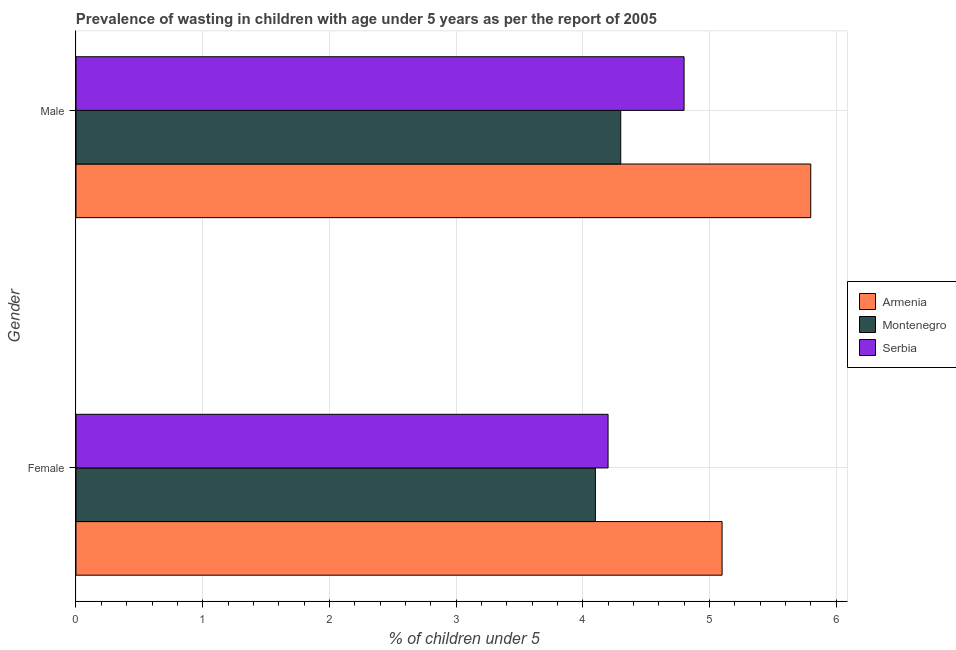Are the number of bars per tick equal to the number of legend labels?
Ensure brevity in your answer.  Yes. How many bars are there on the 1st tick from the bottom?
Provide a succinct answer. 3. What is the percentage of undernourished female children in Armenia?
Ensure brevity in your answer.  5.1. Across all countries, what is the maximum percentage of undernourished female children?
Give a very brief answer. 5.1. Across all countries, what is the minimum percentage of undernourished male children?
Give a very brief answer. 4.3. In which country was the percentage of undernourished male children maximum?
Your answer should be very brief. Armenia. In which country was the percentage of undernourished male children minimum?
Make the answer very short. Montenegro. What is the total percentage of undernourished male children in the graph?
Give a very brief answer. 14.9. What is the difference between the percentage of undernourished female children in Armenia and that in Serbia?
Make the answer very short. 0.9. What is the difference between the percentage of undernourished male children in Armenia and the percentage of undernourished female children in Serbia?
Offer a terse response. 1.6. What is the average percentage of undernourished male children per country?
Ensure brevity in your answer.  4.97. What is the difference between the percentage of undernourished male children and percentage of undernourished female children in Serbia?
Make the answer very short. 0.6. What is the ratio of the percentage of undernourished male children in Armenia to that in Montenegro?
Your response must be concise. 1.35. Is the percentage of undernourished female children in Montenegro less than that in Serbia?
Give a very brief answer. Yes. In how many countries, is the percentage of undernourished female children greater than the average percentage of undernourished female children taken over all countries?
Offer a terse response. 1. What does the 1st bar from the top in Male represents?
Keep it short and to the point. Serbia. What does the 2nd bar from the bottom in Female represents?
Offer a very short reply. Montenegro. Does the graph contain any zero values?
Ensure brevity in your answer.  No. What is the title of the graph?
Your answer should be compact. Prevalence of wasting in children with age under 5 years as per the report of 2005. Does "Spain" appear as one of the legend labels in the graph?
Provide a succinct answer. No. What is the label or title of the X-axis?
Provide a succinct answer.  % of children under 5. What is the label or title of the Y-axis?
Your answer should be compact. Gender. What is the  % of children under 5 of Armenia in Female?
Your answer should be very brief. 5.1. What is the  % of children under 5 of Montenegro in Female?
Your answer should be very brief. 4.1. What is the  % of children under 5 in Serbia in Female?
Your answer should be compact. 4.2. What is the  % of children under 5 of Armenia in Male?
Make the answer very short. 5.8. What is the  % of children under 5 of Montenegro in Male?
Your answer should be compact. 4.3. What is the  % of children under 5 in Serbia in Male?
Your answer should be compact. 4.8. Across all Gender, what is the maximum  % of children under 5 of Armenia?
Give a very brief answer. 5.8. Across all Gender, what is the maximum  % of children under 5 of Montenegro?
Your response must be concise. 4.3. Across all Gender, what is the maximum  % of children under 5 of Serbia?
Make the answer very short. 4.8. Across all Gender, what is the minimum  % of children under 5 in Armenia?
Provide a succinct answer. 5.1. Across all Gender, what is the minimum  % of children under 5 of Montenegro?
Provide a succinct answer. 4.1. Across all Gender, what is the minimum  % of children under 5 of Serbia?
Your answer should be very brief. 4.2. What is the total  % of children under 5 in Montenegro in the graph?
Your response must be concise. 8.4. What is the total  % of children under 5 in Serbia in the graph?
Your answer should be compact. 9. What is the difference between the  % of children under 5 in Montenegro in Female and that in Male?
Keep it short and to the point. -0.2. What is the difference between the  % of children under 5 in Serbia in Female and that in Male?
Your answer should be very brief. -0.6. What is the difference between the  % of children under 5 of Armenia in Female and the  % of children under 5 of Montenegro in Male?
Make the answer very short. 0.8. What is the average  % of children under 5 in Armenia per Gender?
Your answer should be very brief. 5.45. What is the difference between the  % of children under 5 in Armenia and  % of children under 5 in Montenegro in Male?
Make the answer very short. 1.5. What is the difference between the  % of children under 5 of Armenia and  % of children under 5 of Serbia in Male?
Offer a very short reply. 1. What is the ratio of the  % of children under 5 in Armenia in Female to that in Male?
Provide a succinct answer. 0.88. What is the ratio of the  % of children under 5 in Montenegro in Female to that in Male?
Keep it short and to the point. 0.95. What is the ratio of the  % of children under 5 of Serbia in Female to that in Male?
Your answer should be very brief. 0.88. What is the difference between the highest and the second highest  % of children under 5 in Armenia?
Keep it short and to the point. 0.7. What is the difference between the highest and the second highest  % of children under 5 of Montenegro?
Offer a very short reply. 0.2. What is the difference between the highest and the lowest  % of children under 5 in Armenia?
Provide a short and direct response. 0.7. 